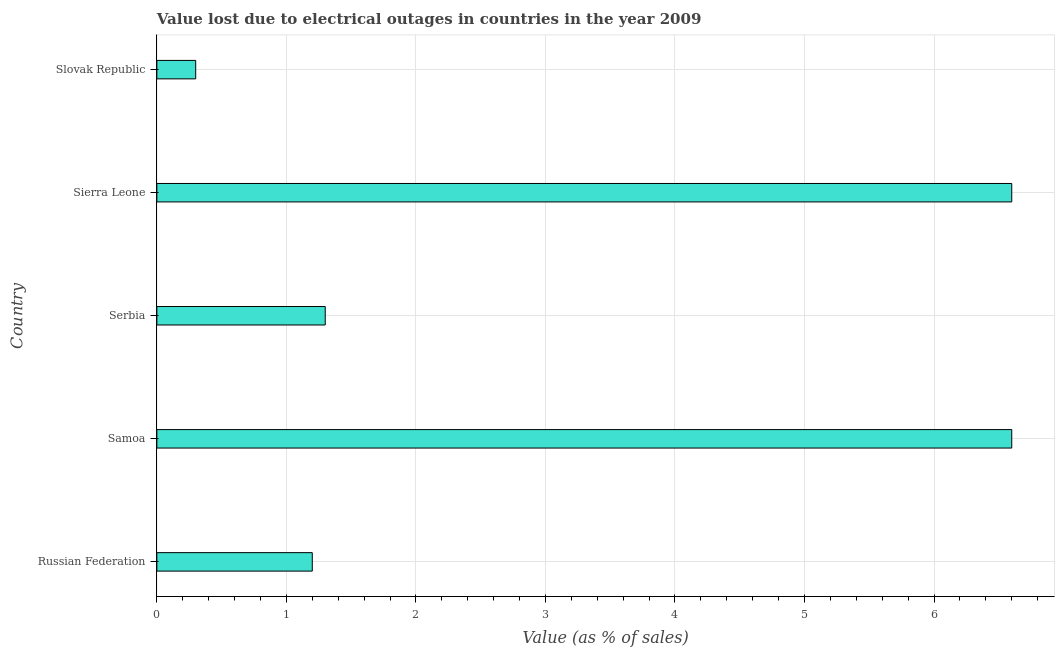What is the title of the graph?
Your answer should be very brief. Value lost due to electrical outages in countries in the year 2009. What is the label or title of the X-axis?
Ensure brevity in your answer.  Value (as % of sales). What is the label or title of the Y-axis?
Your response must be concise. Country. What is the value lost due to electrical outages in Slovak Republic?
Provide a succinct answer. 0.3. Across all countries, what is the minimum value lost due to electrical outages?
Keep it short and to the point. 0.3. In which country was the value lost due to electrical outages maximum?
Your response must be concise. Samoa. In which country was the value lost due to electrical outages minimum?
Provide a short and direct response. Slovak Republic. What is the sum of the value lost due to electrical outages?
Your answer should be compact. 16. What is the difference between the value lost due to electrical outages in Serbia and Slovak Republic?
Provide a succinct answer. 1. In how many countries, is the value lost due to electrical outages greater than 2.4 %?
Ensure brevity in your answer.  2. What is the ratio of the value lost due to electrical outages in Russian Federation to that in Samoa?
Offer a very short reply. 0.18. Is the value lost due to electrical outages in Russian Federation less than that in Sierra Leone?
Make the answer very short. Yes. What is the difference between the highest and the lowest value lost due to electrical outages?
Your response must be concise. 6.3. Are all the bars in the graph horizontal?
Your answer should be compact. Yes. How many countries are there in the graph?
Provide a short and direct response. 5. What is the difference between two consecutive major ticks on the X-axis?
Make the answer very short. 1. What is the Value (as % of sales) of Samoa?
Ensure brevity in your answer.  6.6. What is the Value (as % of sales) in Slovak Republic?
Offer a terse response. 0.3. What is the difference between the Value (as % of sales) in Russian Federation and Serbia?
Keep it short and to the point. -0.1. What is the difference between the Value (as % of sales) in Russian Federation and Sierra Leone?
Your answer should be compact. -5.4. What is the difference between the Value (as % of sales) in Samoa and Serbia?
Offer a very short reply. 5.3. What is the difference between the Value (as % of sales) in Samoa and Slovak Republic?
Your answer should be compact. 6.3. What is the difference between the Value (as % of sales) in Serbia and Sierra Leone?
Ensure brevity in your answer.  -5.3. What is the difference between the Value (as % of sales) in Serbia and Slovak Republic?
Your answer should be very brief. 1. What is the ratio of the Value (as % of sales) in Russian Federation to that in Samoa?
Your answer should be compact. 0.18. What is the ratio of the Value (as % of sales) in Russian Federation to that in Serbia?
Your answer should be compact. 0.92. What is the ratio of the Value (as % of sales) in Russian Federation to that in Sierra Leone?
Make the answer very short. 0.18. What is the ratio of the Value (as % of sales) in Russian Federation to that in Slovak Republic?
Ensure brevity in your answer.  4. What is the ratio of the Value (as % of sales) in Samoa to that in Serbia?
Provide a short and direct response. 5.08. What is the ratio of the Value (as % of sales) in Samoa to that in Slovak Republic?
Provide a short and direct response. 22. What is the ratio of the Value (as % of sales) in Serbia to that in Sierra Leone?
Your response must be concise. 0.2. What is the ratio of the Value (as % of sales) in Serbia to that in Slovak Republic?
Provide a succinct answer. 4.33. 